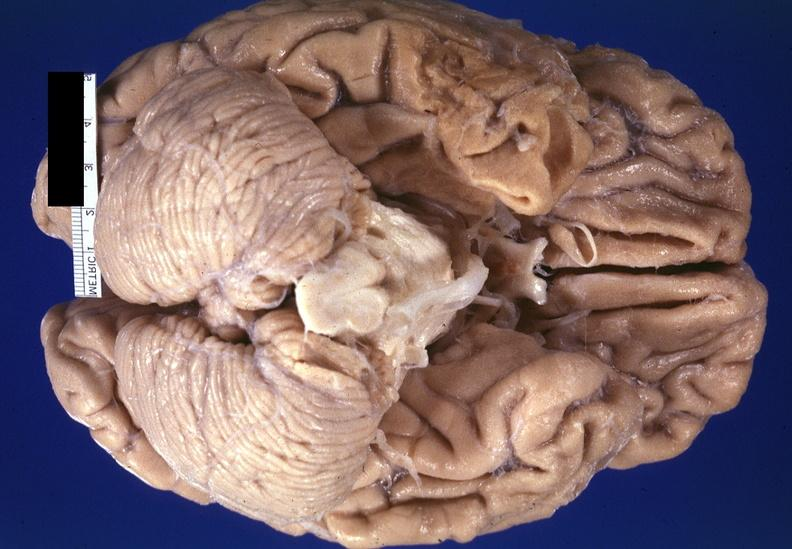does this image show brain, frontal lobe atrophy, pick 's disease?
Answer the question using a single word or phrase. Yes 